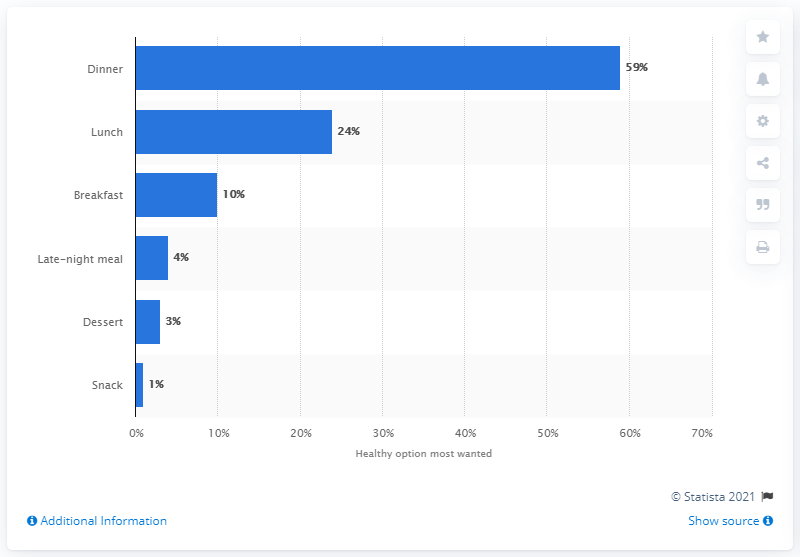Give some essential details in this illustration. According to a survey, a significant number of consumers prefer to eat low-calorie or healthy food options during lunch, as reported by 24% of respondents. 